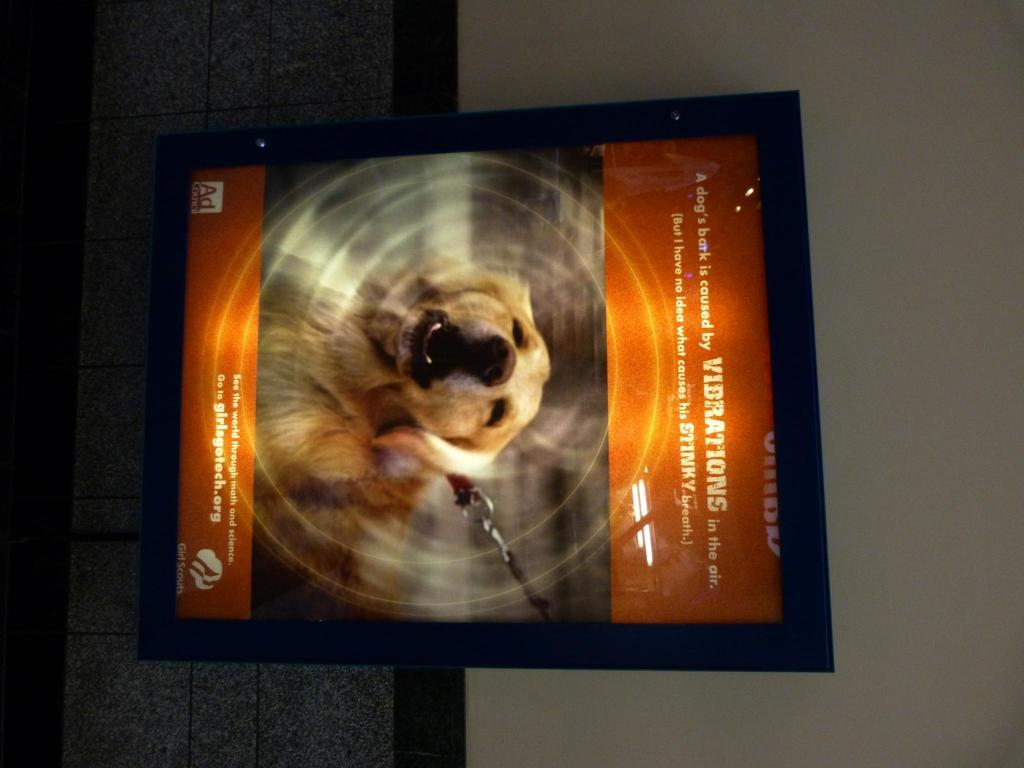What object is present in the image that holds a picture? There is a photo frame in the image. What is depicted in the photo frame? The photo frame contains a picture of a dog. Can you describe the dog in the photo? The dog in the photo is brown in color. Where is the photo frame located in the image? The photo frame is attached to a wall. What colors can be seen on the wall in the image? The wall is white, black, and ash in color. What type of fruit is hanging from the dog's eye in the image? There is no fruit or dog's eye present in the image; it features a photo frame with a picture of a brown dog. 